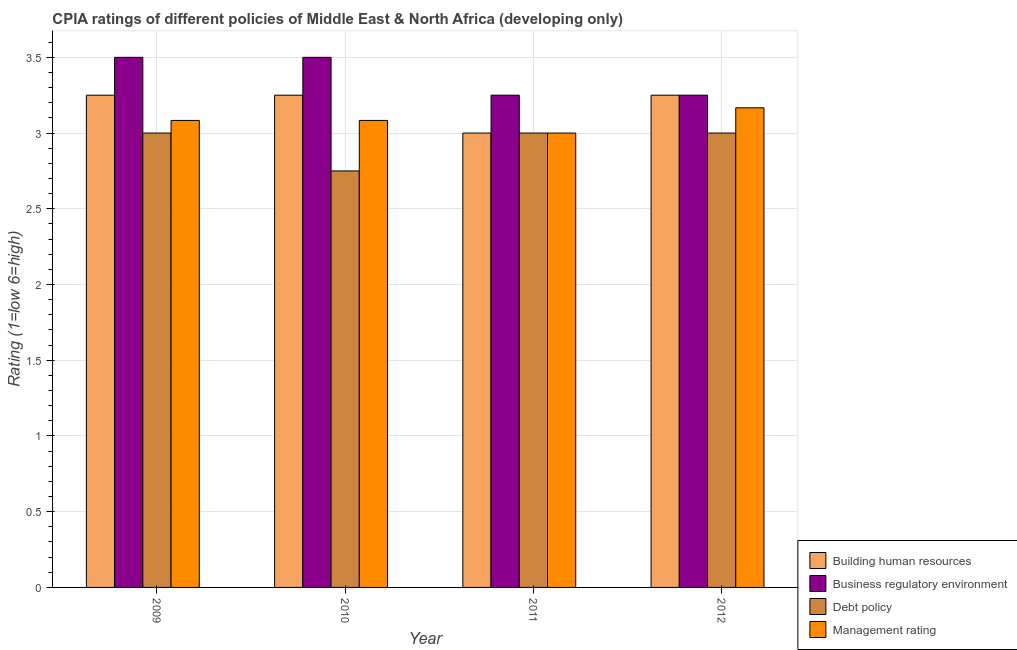How many different coloured bars are there?
Offer a very short reply. 4. How many groups of bars are there?
Give a very brief answer. 4. Are the number of bars on each tick of the X-axis equal?
Offer a very short reply. Yes. How many bars are there on the 1st tick from the right?
Your response must be concise. 4. What is the label of the 2nd group of bars from the left?
Keep it short and to the point. 2010. Across all years, what is the maximum cpia rating of business regulatory environment?
Give a very brief answer. 3.5. Across all years, what is the minimum cpia rating of debt policy?
Offer a very short reply. 2.75. In which year was the cpia rating of management maximum?
Offer a very short reply. 2012. In which year was the cpia rating of management minimum?
Keep it short and to the point. 2011. What is the total cpia rating of management in the graph?
Your response must be concise. 12.33. What is the difference between the cpia rating of management in 2011 and that in 2012?
Make the answer very short. -0.17. What is the difference between the cpia rating of building human resources in 2012 and the cpia rating of management in 2011?
Make the answer very short. 0.25. What is the average cpia rating of business regulatory environment per year?
Offer a terse response. 3.38. What is the ratio of the cpia rating of debt policy in 2010 to that in 2011?
Your answer should be compact. 0.92. Is the difference between the cpia rating of business regulatory environment in 2009 and 2012 greater than the difference between the cpia rating of management in 2009 and 2012?
Your answer should be very brief. No. What is the difference between the highest and the second highest cpia rating of business regulatory environment?
Your response must be concise. 0. What is the difference between the highest and the lowest cpia rating of management?
Your answer should be very brief. 0.17. In how many years, is the cpia rating of debt policy greater than the average cpia rating of debt policy taken over all years?
Make the answer very short. 3. Is it the case that in every year, the sum of the cpia rating of management and cpia rating of debt policy is greater than the sum of cpia rating of business regulatory environment and cpia rating of building human resources?
Keep it short and to the point. No. What does the 2nd bar from the left in 2011 represents?
Offer a terse response. Business regulatory environment. What does the 2nd bar from the right in 2009 represents?
Offer a very short reply. Debt policy. Is it the case that in every year, the sum of the cpia rating of building human resources and cpia rating of business regulatory environment is greater than the cpia rating of debt policy?
Keep it short and to the point. Yes. How many years are there in the graph?
Give a very brief answer. 4. Are the values on the major ticks of Y-axis written in scientific E-notation?
Give a very brief answer. No. Does the graph contain any zero values?
Provide a succinct answer. No. Does the graph contain grids?
Your answer should be compact. Yes. Where does the legend appear in the graph?
Offer a terse response. Bottom right. How many legend labels are there?
Provide a succinct answer. 4. How are the legend labels stacked?
Offer a very short reply. Vertical. What is the title of the graph?
Offer a very short reply. CPIA ratings of different policies of Middle East & North Africa (developing only). Does "Grants and Revenue" appear as one of the legend labels in the graph?
Ensure brevity in your answer.  No. What is the Rating (1=low 6=high) in Debt policy in 2009?
Offer a very short reply. 3. What is the Rating (1=low 6=high) in Management rating in 2009?
Make the answer very short. 3.08. What is the Rating (1=low 6=high) of Building human resources in 2010?
Offer a very short reply. 3.25. What is the Rating (1=low 6=high) of Business regulatory environment in 2010?
Your answer should be very brief. 3.5. What is the Rating (1=low 6=high) of Debt policy in 2010?
Your response must be concise. 2.75. What is the Rating (1=low 6=high) in Management rating in 2010?
Provide a succinct answer. 3.08. What is the Rating (1=low 6=high) in Debt policy in 2011?
Keep it short and to the point. 3. What is the Rating (1=low 6=high) in Management rating in 2011?
Keep it short and to the point. 3. What is the Rating (1=low 6=high) in Debt policy in 2012?
Give a very brief answer. 3. What is the Rating (1=low 6=high) in Management rating in 2012?
Offer a very short reply. 3.17. Across all years, what is the maximum Rating (1=low 6=high) of Business regulatory environment?
Offer a very short reply. 3.5. Across all years, what is the maximum Rating (1=low 6=high) of Management rating?
Make the answer very short. 3.17. Across all years, what is the minimum Rating (1=low 6=high) of Business regulatory environment?
Ensure brevity in your answer.  3.25. Across all years, what is the minimum Rating (1=low 6=high) of Debt policy?
Give a very brief answer. 2.75. What is the total Rating (1=low 6=high) of Building human resources in the graph?
Ensure brevity in your answer.  12.75. What is the total Rating (1=low 6=high) of Business regulatory environment in the graph?
Give a very brief answer. 13.5. What is the total Rating (1=low 6=high) in Debt policy in the graph?
Offer a very short reply. 11.75. What is the total Rating (1=low 6=high) of Management rating in the graph?
Provide a succinct answer. 12.33. What is the difference between the Rating (1=low 6=high) in Building human resources in 2009 and that in 2010?
Your response must be concise. 0. What is the difference between the Rating (1=low 6=high) in Business regulatory environment in 2009 and that in 2010?
Keep it short and to the point. 0. What is the difference between the Rating (1=low 6=high) of Management rating in 2009 and that in 2010?
Your response must be concise. 0. What is the difference between the Rating (1=low 6=high) of Building human resources in 2009 and that in 2011?
Offer a terse response. 0.25. What is the difference between the Rating (1=low 6=high) of Management rating in 2009 and that in 2011?
Provide a short and direct response. 0.08. What is the difference between the Rating (1=low 6=high) of Building human resources in 2009 and that in 2012?
Provide a short and direct response. 0. What is the difference between the Rating (1=low 6=high) of Management rating in 2009 and that in 2012?
Your answer should be compact. -0.08. What is the difference between the Rating (1=low 6=high) in Building human resources in 2010 and that in 2011?
Provide a succinct answer. 0.25. What is the difference between the Rating (1=low 6=high) of Management rating in 2010 and that in 2011?
Ensure brevity in your answer.  0.08. What is the difference between the Rating (1=low 6=high) in Building human resources in 2010 and that in 2012?
Offer a terse response. 0. What is the difference between the Rating (1=low 6=high) in Management rating in 2010 and that in 2012?
Give a very brief answer. -0.08. What is the difference between the Rating (1=low 6=high) in Building human resources in 2011 and that in 2012?
Offer a terse response. -0.25. What is the difference between the Rating (1=low 6=high) in Debt policy in 2011 and that in 2012?
Offer a very short reply. 0. What is the difference between the Rating (1=low 6=high) in Management rating in 2011 and that in 2012?
Keep it short and to the point. -0.17. What is the difference between the Rating (1=low 6=high) in Building human resources in 2009 and the Rating (1=low 6=high) in Business regulatory environment in 2010?
Your answer should be compact. -0.25. What is the difference between the Rating (1=low 6=high) in Building human resources in 2009 and the Rating (1=low 6=high) in Debt policy in 2010?
Keep it short and to the point. 0.5. What is the difference between the Rating (1=low 6=high) in Business regulatory environment in 2009 and the Rating (1=low 6=high) in Management rating in 2010?
Your answer should be very brief. 0.42. What is the difference between the Rating (1=low 6=high) of Debt policy in 2009 and the Rating (1=low 6=high) of Management rating in 2010?
Your answer should be compact. -0.08. What is the difference between the Rating (1=low 6=high) in Building human resources in 2009 and the Rating (1=low 6=high) in Business regulatory environment in 2011?
Keep it short and to the point. 0. What is the difference between the Rating (1=low 6=high) of Building human resources in 2009 and the Rating (1=low 6=high) of Management rating in 2011?
Keep it short and to the point. 0.25. What is the difference between the Rating (1=low 6=high) of Building human resources in 2009 and the Rating (1=low 6=high) of Business regulatory environment in 2012?
Provide a short and direct response. 0. What is the difference between the Rating (1=low 6=high) of Building human resources in 2009 and the Rating (1=low 6=high) of Debt policy in 2012?
Provide a succinct answer. 0.25. What is the difference between the Rating (1=low 6=high) in Building human resources in 2009 and the Rating (1=low 6=high) in Management rating in 2012?
Your answer should be compact. 0.08. What is the difference between the Rating (1=low 6=high) of Business regulatory environment in 2009 and the Rating (1=low 6=high) of Debt policy in 2012?
Your response must be concise. 0.5. What is the difference between the Rating (1=low 6=high) in Business regulatory environment in 2009 and the Rating (1=low 6=high) in Management rating in 2012?
Your answer should be compact. 0.33. What is the difference between the Rating (1=low 6=high) in Building human resources in 2010 and the Rating (1=low 6=high) in Business regulatory environment in 2011?
Offer a very short reply. 0. What is the difference between the Rating (1=low 6=high) in Business regulatory environment in 2010 and the Rating (1=low 6=high) in Management rating in 2011?
Offer a very short reply. 0.5. What is the difference between the Rating (1=low 6=high) in Debt policy in 2010 and the Rating (1=low 6=high) in Management rating in 2011?
Your response must be concise. -0.25. What is the difference between the Rating (1=low 6=high) of Building human resources in 2010 and the Rating (1=low 6=high) of Debt policy in 2012?
Offer a terse response. 0.25. What is the difference between the Rating (1=low 6=high) in Building human resources in 2010 and the Rating (1=low 6=high) in Management rating in 2012?
Keep it short and to the point. 0.08. What is the difference between the Rating (1=low 6=high) in Business regulatory environment in 2010 and the Rating (1=low 6=high) in Debt policy in 2012?
Keep it short and to the point. 0.5. What is the difference between the Rating (1=low 6=high) in Business regulatory environment in 2010 and the Rating (1=low 6=high) in Management rating in 2012?
Offer a terse response. 0.33. What is the difference between the Rating (1=low 6=high) in Debt policy in 2010 and the Rating (1=low 6=high) in Management rating in 2012?
Give a very brief answer. -0.42. What is the difference between the Rating (1=low 6=high) of Building human resources in 2011 and the Rating (1=low 6=high) of Business regulatory environment in 2012?
Your answer should be very brief. -0.25. What is the difference between the Rating (1=low 6=high) in Building human resources in 2011 and the Rating (1=low 6=high) in Debt policy in 2012?
Your answer should be very brief. 0. What is the difference between the Rating (1=low 6=high) in Building human resources in 2011 and the Rating (1=low 6=high) in Management rating in 2012?
Your response must be concise. -0.17. What is the difference between the Rating (1=low 6=high) of Business regulatory environment in 2011 and the Rating (1=low 6=high) of Management rating in 2012?
Keep it short and to the point. 0.08. What is the average Rating (1=low 6=high) in Building human resources per year?
Make the answer very short. 3.19. What is the average Rating (1=low 6=high) in Business regulatory environment per year?
Give a very brief answer. 3.38. What is the average Rating (1=low 6=high) in Debt policy per year?
Your answer should be very brief. 2.94. What is the average Rating (1=low 6=high) in Management rating per year?
Keep it short and to the point. 3.08. In the year 2009, what is the difference between the Rating (1=low 6=high) of Building human resources and Rating (1=low 6=high) of Debt policy?
Make the answer very short. 0.25. In the year 2009, what is the difference between the Rating (1=low 6=high) of Building human resources and Rating (1=low 6=high) of Management rating?
Your answer should be compact. 0.17. In the year 2009, what is the difference between the Rating (1=low 6=high) in Business regulatory environment and Rating (1=low 6=high) in Debt policy?
Keep it short and to the point. 0.5. In the year 2009, what is the difference between the Rating (1=low 6=high) in Business regulatory environment and Rating (1=low 6=high) in Management rating?
Your response must be concise. 0.42. In the year 2009, what is the difference between the Rating (1=low 6=high) in Debt policy and Rating (1=low 6=high) in Management rating?
Offer a terse response. -0.08. In the year 2010, what is the difference between the Rating (1=low 6=high) in Building human resources and Rating (1=low 6=high) in Business regulatory environment?
Provide a short and direct response. -0.25. In the year 2010, what is the difference between the Rating (1=low 6=high) of Building human resources and Rating (1=low 6=high) of Debt policy?
Offer a very short reply. 0.5. In the year 2010, what is the difference between the Rating (1=low 6=high) of Business regulatory environment and Rating (1=low 6=high) of Management rating?
Offer a very short reply. 0.42. In the year 2011, what is the difference between the Rating (1=low 6=high) in Building human resources and Rating (1=low 6=high) in Debt policy?
Give a very brief answer. 0. In the year 2011, what is the difference between the Rating (1=low 6=high) in Building human resources and Rating (1=low 6=high) in Management rating?
Keep it short and to the point. 0. In the year 2011, what is the difference between the Rating (1=low 6=high) in Business regulatory environment and Rating (1=low 6=high) in Debt policy?
Your response must be concise. 0.25. In the year 2011, what is the difference between the Rating (1=low 6=high) of Business regulatory environment and Rating (1=low 6=high) of Management rating?
Offer a very short reply. 0.25. In the year 2011, what is the difference between the Rating (1=low 6=high) of Debt policy and Rating (1=low 6=high) of Management rating?
Your answer should be compact. 0. In the year 2012, what is the difference between the Rating (1=low 6=high) of Building human resources and Rating (1=low 6=high) of Business regulatory environment?
Offer a terse response. 0. In the year 2012, what is the difference between the Rating (1=low 6=high) of Building human resources and Rating (1=low 6=high) of Debt policy?
Give a very brief answer. 0.25. In the year 2012, what is the difference between the Rating (1=low 6=high) of Building human resources and Rating (1=low 6=high) of Management rating?
Ensure brevity in your answer.  0.08. In the year 2012, what is the difference between the Rating (1=low 6=high) in Business regulatory environment and Rating (1=low 6=high) in Debt policy?
Provide a short and direct response. 0.25. In the year 2012, what is the difference between the Rating (1=low 6=high) of Business regulatory environment and Rating (1=low 6=high) of Management rating?
Your answer should be very brief. 0.08. What is the ratio of the Rating (1=low 6=high) in Business regulatory environment in 2009 to that in 2010?
Ensure brevity in your answer.  1. What is the ratio of the Rating (1=low 6=high) of Management rating in 2009 to that in 2011?
Provide a short and direct response. 1.03. What is the ratio of the Rating (1=low 6=high) in Debt policy in 2009 to that in 2012?
Ensure brevity in your answer.  1. What is the ratio of the Rating (1=low 6=high) of Management rating in 2009 to that in 2012?
Offer a terse response. 0.97. What is the ratio of the Rating (1=low 6=high) in Management rating in 2010 to that in 2011?
Offer a very short reply. 1.03. What is the ratio of the Rating (1=low 6=high) in Building human resources in 2010 to that in 2012?
Offer a terse response. 1. What is the ratio of the Rating (1=low 6=high) in Business regulatory environment in 2010 to that in 2012?
Your answer should be very brief. 1.08. What is the ratio of the Rating (1=low 6=high) of Debt policy in 2010 to that in 2012?
Offer a very short reply. 0.92. What is the ratio of the Rating (1=low 6=high) of Management rating in 2010 to that in 2012?
Offer a terse response. 0.97. What is the ratio of the Rating (1=low 6=high) in Business regulatory environment in 2011 to that in 2012?
Keep it short and to the point. 1. What is the ratio of the Rating (1=low 6=high) in Debt policy in 2011 to that in 2012?
Provide a short and direct response. 1. What is the ratio of the Rating (1=low 6=high) of Management rating in 2011 to that in 2012?
Provide a short and direct response. 0.95. What is the difference between the highest and the second highest Rating (1=low 6=high) of Business regulatory environment?
Provide a succinct answer. 0. What is the difference between the highest and the second highest Rating (1=low 6=high) of Debt policy?
Offer a terse response. 0. What is the difference between the highest and the second highest Rating (1=low 6=high) in Management rating?
Ensure brevity in your answer.  0.08. What is the difference between the highest and the lowest Rating (1=low 6=high) in Business regulatory environment?
Your answer should be very brief. 0.25. 